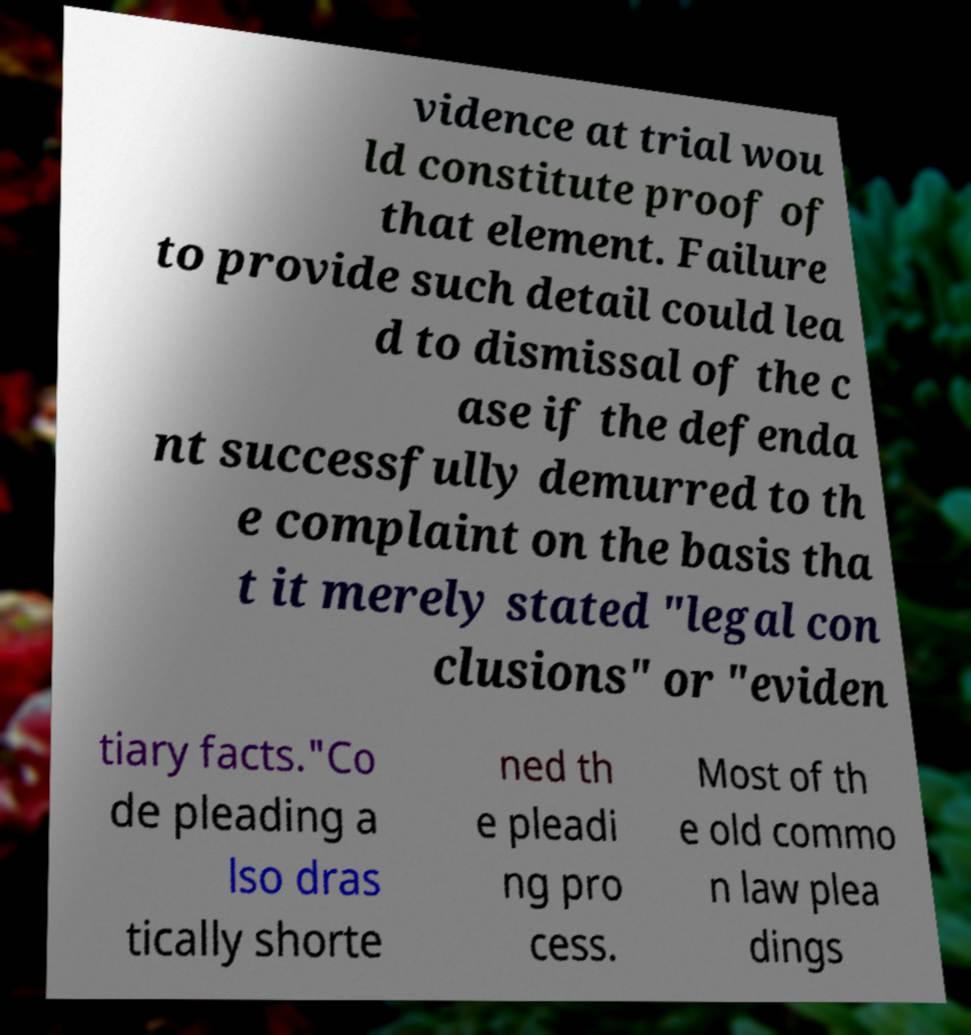For documentation purposes, I need the text within this image transcribed. Could you provide that? vidence at trial wou ld constitute proof of that element. Failure to provide such detail could lea d to dismissal of the c ase if the defenda nt successfully demurred to th e complaint on the basis tha t it merely stated "legal con clusions" or "eviden tiary facts."Co de pleading a lso dras tically shorte ned th e pleadi ng pro cess. Most of th e old commo n law plea dings 